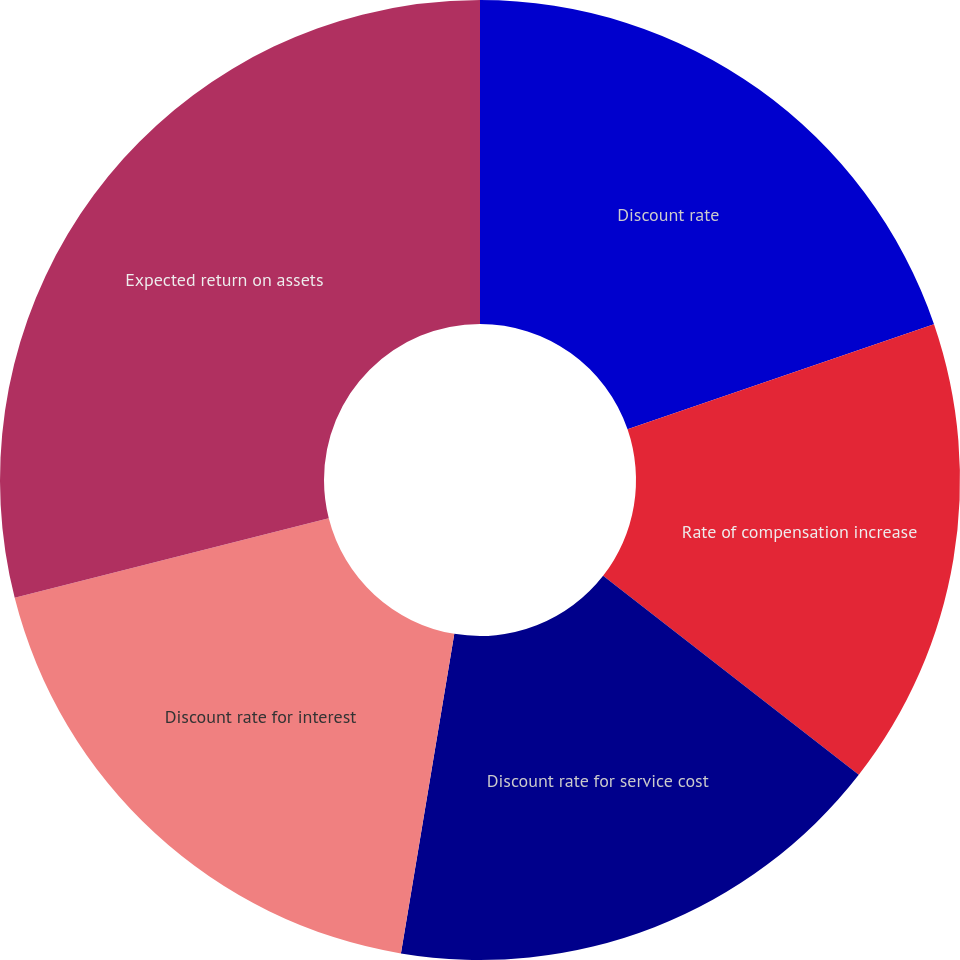Convert chart to OTSL. <chart><loc_0><loc_0><loc_500><loc_500><pie_chart><fcel>Discount rate<fcel>Rate of compensation increase<fcel>Discount rate for service cost<fcel>Discount rate for interest<fcel>Expected return on assets<nl><fcel>19.74%<fcel>15.79%<fcel>17.11%<fcel>18.42%<fcel>28.95%<nl></chart> 